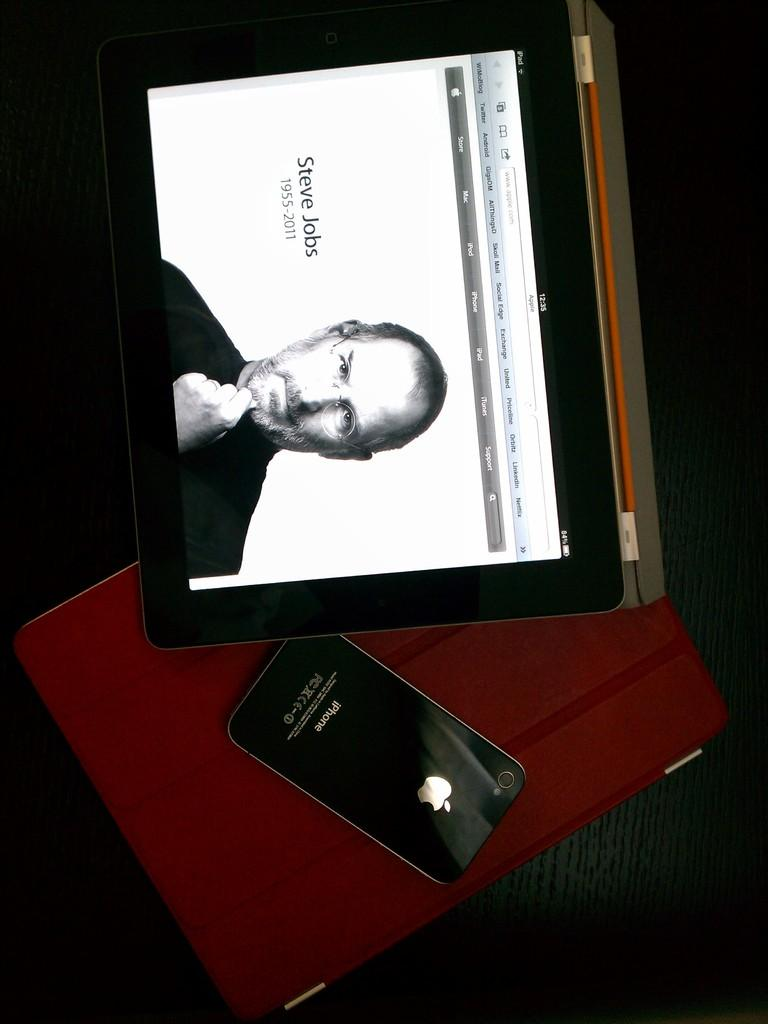<image>
Relay a brief, clear account of the picture shown. Black iPhone next to a screen saying Steve Jobs. 